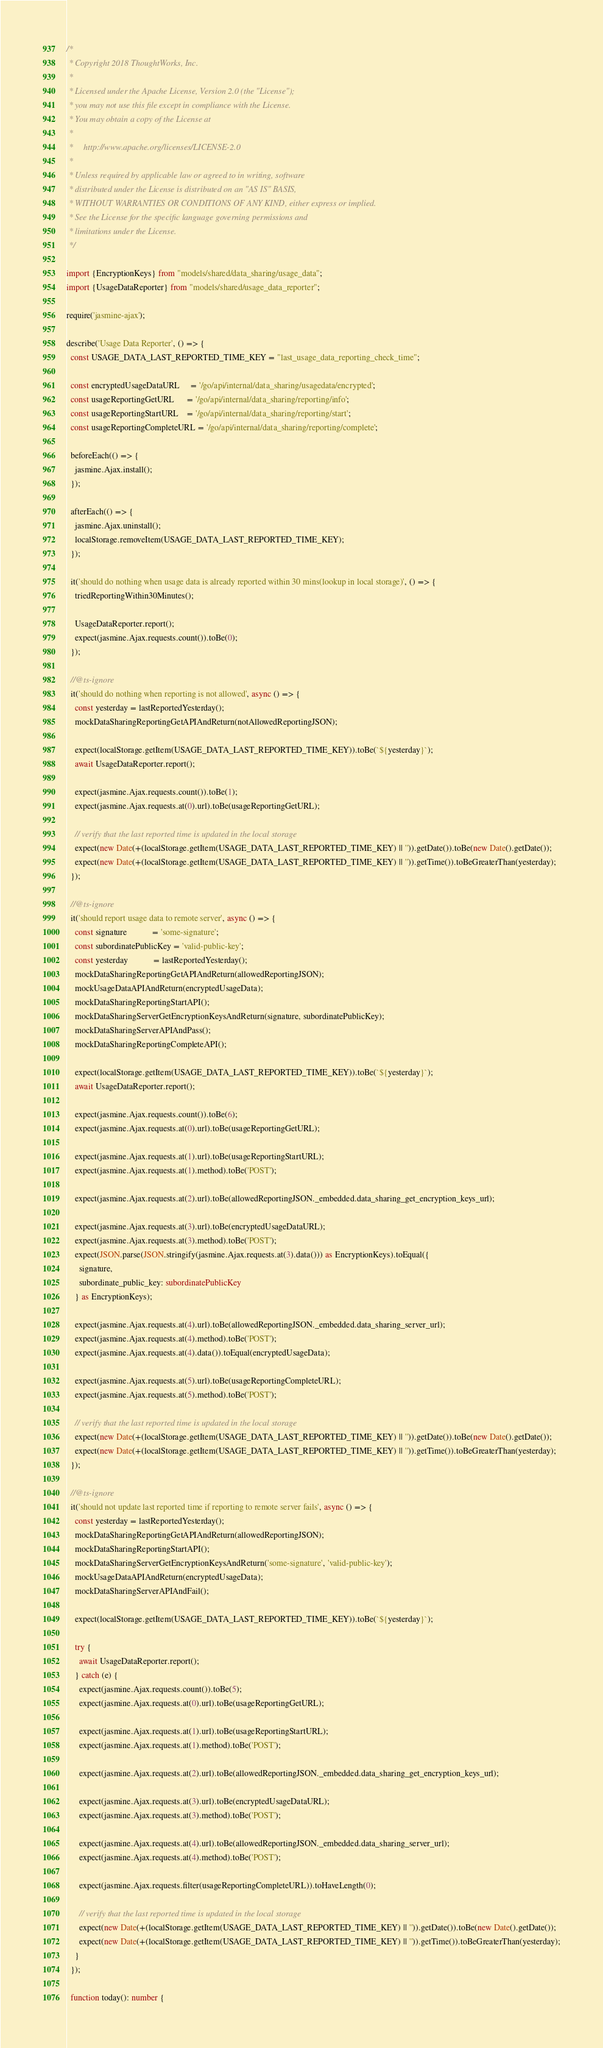<code> <loc_0><loc_0><loc_500><loc_500><_TypeScript_>/*
 * Copyright 2018 ThoughtWorks, Inc.
 *
 * Licensed under the Apache License, Version 2.0 (the "License");
 * you may not use this file except in compliance with the License.
 * You may obtain a copy of the License at
 *
 *     http://www.apache.org/licenses/LICENSE-2.0
 *
 * Unless required by applicable law or agreed to in writing, software
 * distributed under the License is distributed on an "AS IS" BASIS,
 * WITHOUT WARRANTIES OR CONDITIONS OF ANY KIND, either express or implied.
 * See the License for the specific language governing permissions and
 * limitations under the License.
 */

import {EncryptionKeys} from "models/shared/data_sharing/usage_data";
import {UsageDataReporter} from "models/shared/usage_data_reporter";

require('jasmine-ajax');

describe('Usage Data Reporter', () => {
  const USAGE_DATA_LAST_REPORTED_TIME_KEY = "last_usage_data_reporting_check_time";

  const encryptedUsageDataURL     = '/go/api/internal/data_sharing/usagedata/encrypted';
  const usageReportingGetURL      = '/go/api/internal/data_sharing/reporting/info';
  const usageReportingStartURL    = '/go/api/internal/data_sharing/reporting/start';
  const usageReportingCompleteURL = '/go/api/internal/data_sharing/reporting/complete';

  beforeEach(() => {
    jasmine.Ajax.install();
  });

  afterEach(() => {
    jasmine.Ajax.uninstall();
    localStorage.removeItem(USAGE_DATA_LAST_REPORTED_TIME_KEY);
  });

  it('should do nothing when usage data is already reported within 30 mins(lookup in local storage)', () => {
    triedReportingWithin30Minutes();

    UsageDataReporter.report();
    expect(jasmine.Ajax.requests.count()).toBe(0);
  });

  //@ts-ignore
  it('should do nothing when reporting is not allowed', async () => {
    const yesterday = lastReportedYesterday();
    mockDataSharingReportingGetAPIAndReturn(notAllowedReportingJSON);

    expect(localStorage.getItem(USAGE_DATA_LAST_REPORTED_TIME_KEY)).toBe(`${yesterday}`);
    await UsageDataReporter.report();

    expect(jasmine.Ajax.requests.count()).toBe(1);
    expect(jasmine.Ajax.requests.at(0).url).toBe(usageReportingGetURL);

    // verify that the last reported time is updated in the local storage
    expect(new Date(+(localStorage.getItem(USAGE_DATA_LAST_REPORTED_TIME_KEY) || '')).getDate()).toBe(new Date().getDate());
    expect(new Date(+(localStorage.getItem(USAGE_DATA_LAST_REPORTED_TIME_KEY) || '')).getTime()).toBeGreaterThan(yesterday);
  });

  //@ts-ignore
  it('should report usage data to remote server', async () => {
    const signature            = 'some-signature';
    const subordinatePublicKey = 'valid-public-key';
    const yesterday            = lastReportedYesterday();
    mockDataSharingReportingGetAPIAndReturn(allowedReportingJSON);
    mockUsageDataAPIAndReturn(encryptedUsageData);
    mockDataSharingReportingStartAPI();
    mockDataSharingServerGetEncryptionKeysAndReturn(signature, subordinatePublicKey);
    mockDataSharingServerAPIAndPass();
    mockDataSharingReportingCompleteAPI();

    expect(localStorage.getItem(USAGE_DATA_LAST_REPORTED_TIME_KEY)).toBe(`${yesterday}`);
    await UsageDataReporter.report();

    expect(jasmine.Ajax.requests.count()).toBe(6);
    expect(jasmine.Ajax.requests.at(0).url).toBe(usageReportingGetURL);

    expect(jasmine.Ajax.requests.at(1).url).toBe(usageReportingStartURL);
    expect(jasmine.Ajax.requests.at(1).method).toBe('POST');

    expect(jasmine.Ajax.requests.at(2).url).toBe(allowedReportingJSON._embedded.data_sharing_get_encryption_keys_url);

    expect(jasmine.Ajax.requests.at(3).url).toBe(encryptedUsageDataURL);
    expect(jasmine.Ajax.requests.at(3).method).toBe('POST');
    expect(JSON.parse(JSON.stringify(jasmine.Ajax.requests.at(3).data())) as EncryptionKeys).toEqual({
      signature,
      subordinate_public_key: subordinatePublicKey
    } as EncryptionKeys);

    expect(jasmine.Ajax.requests.at(4).url).toBe(allowedReportingJSON._embedded.data_sharing_server_url);
    expect(jasmine.Ajax.requests.at(4).method).toBe('POST');
    expect(jasmine.Ajax.requests.at(4).data()).toEqual(encryptedUsageData);

    expect(jasmine.Ajax.requests.at(5).url).toBe(usageReportingCompleteURL);
    expect(jasmine.Ajax.requests.at(5).method).toBe('POST');

    // verify that the last reported time is updated in the local storage
    expect(new Date(+(localStorage.getItem(USAGE_DATA_LAST_REPORTED_TIME_KEY) || '')).getDate()).toBe(new Date().getDate());
    expect(new Date(+(localStorage.getItem(USAGE_DATA_LAST_REPORTED_TIME_KEY) || '')).getTime()).toBeGreaterThan(yesterday);
  });

  //@ts-ignore
  it('should not update last reported time if reporting to remote server fails', async () => {
    const yesterday = lastReportedYesterday();
    mockDataSharingReportingGetAPIAndReturn(allowedReportingJSON);
    mockDataSharingReportingStartAPI();
    mockDataSharingServerGetEncryptionKeysAndReturn('some-signature', 'valid-public-key');
    mockUsageDataAPIAndReturn(encryptedUsageData);
    mockDataSharingServerAPIAndFail();

    expect(localStorage.getItem(USAGE_DATA_LAST_REPORTED_TIME_KEY)).toBe(`${yesterday}`);

    try {
      await UsageDataReporter.report();
    } catch (e) {
      expect(jasmine.Ajax.requests.count()).toBe(5);
      expect(jasmine.Ajax.requests.at(0).url).toBe(usageReportingGetURL);

      expect(jasmine.Ajax.requests.at(1).url).toBe(usageReportingStartURL);
      expect(jasmine.Ajax.requests.at(1).method).toBe('POST');

      expect(jasmine.Ajax.requests.at(2).url).toBe(allowedReportingJSON._embedded.data_sharing_get_encryption_keys_url);

      expect(jasmine.Ajax.requests.at(3).url).toBe(encryptedUsageDataURL);
      expect(jasmine.Ajax.requests.at(3).method).toBe('POST');

      expect(jasmine.Ajax.requests.at(4).url).toBe(allowedReportingJSON._embedded.data_sharing_server_url);
      expect(jasmine.Ajax.requests.at(4).method).toBe('POST');

      expect(jasmine.Ajax.requests.filter(usageReportingCompleteURL)).toHaveLength(0);

      // verify that the last reported time is updated in the local storage
      expect(new Date(+(localStorage.getItem(USAGE_DATA_LAST_REPORTED_TIME_KEY) || '')).getDate()).toBe(new Date().getDate());
      expect(new Date(+(localStorage.getItem(USAGE_DATA_LAST_REPORTED_TIME_KEY) || '')).getTime()).toBeGreaterThan(yesterday);
    }
  });

  function today(): number {</code> 